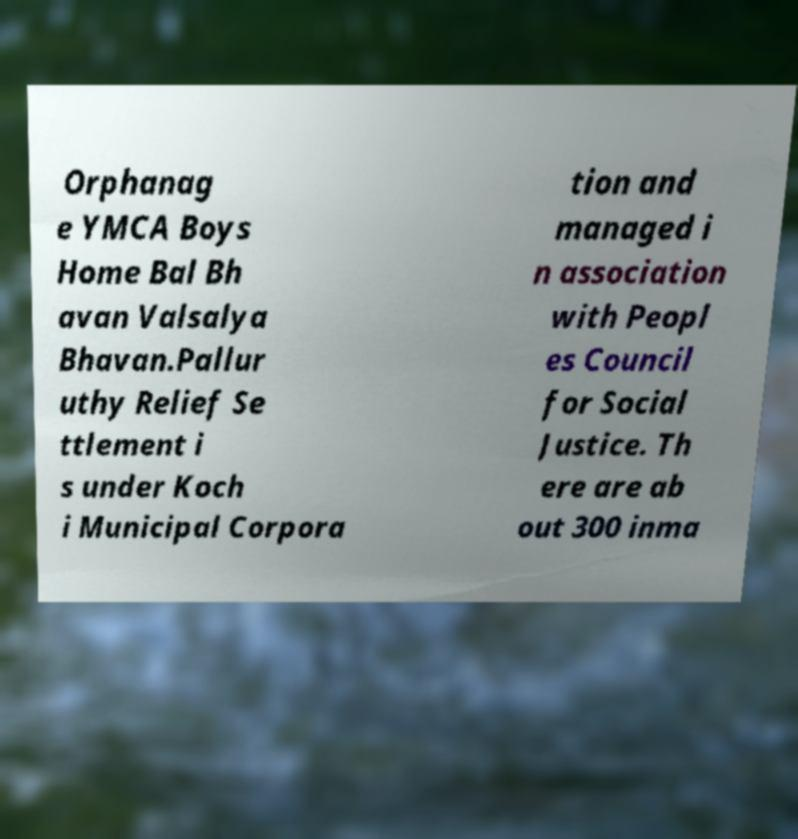Could you assist in decoding the text presented in this image and type it out clearly? Orphanag e YMCA Boys Home Bal Bh avan Valsalya Bhavan.Pallur uthy Relief Se ttlement i s under Koch i Municipal Corpora tion and managed i n association with Peopl es Council for Social Justice. Th ere are ab out 300 inma 